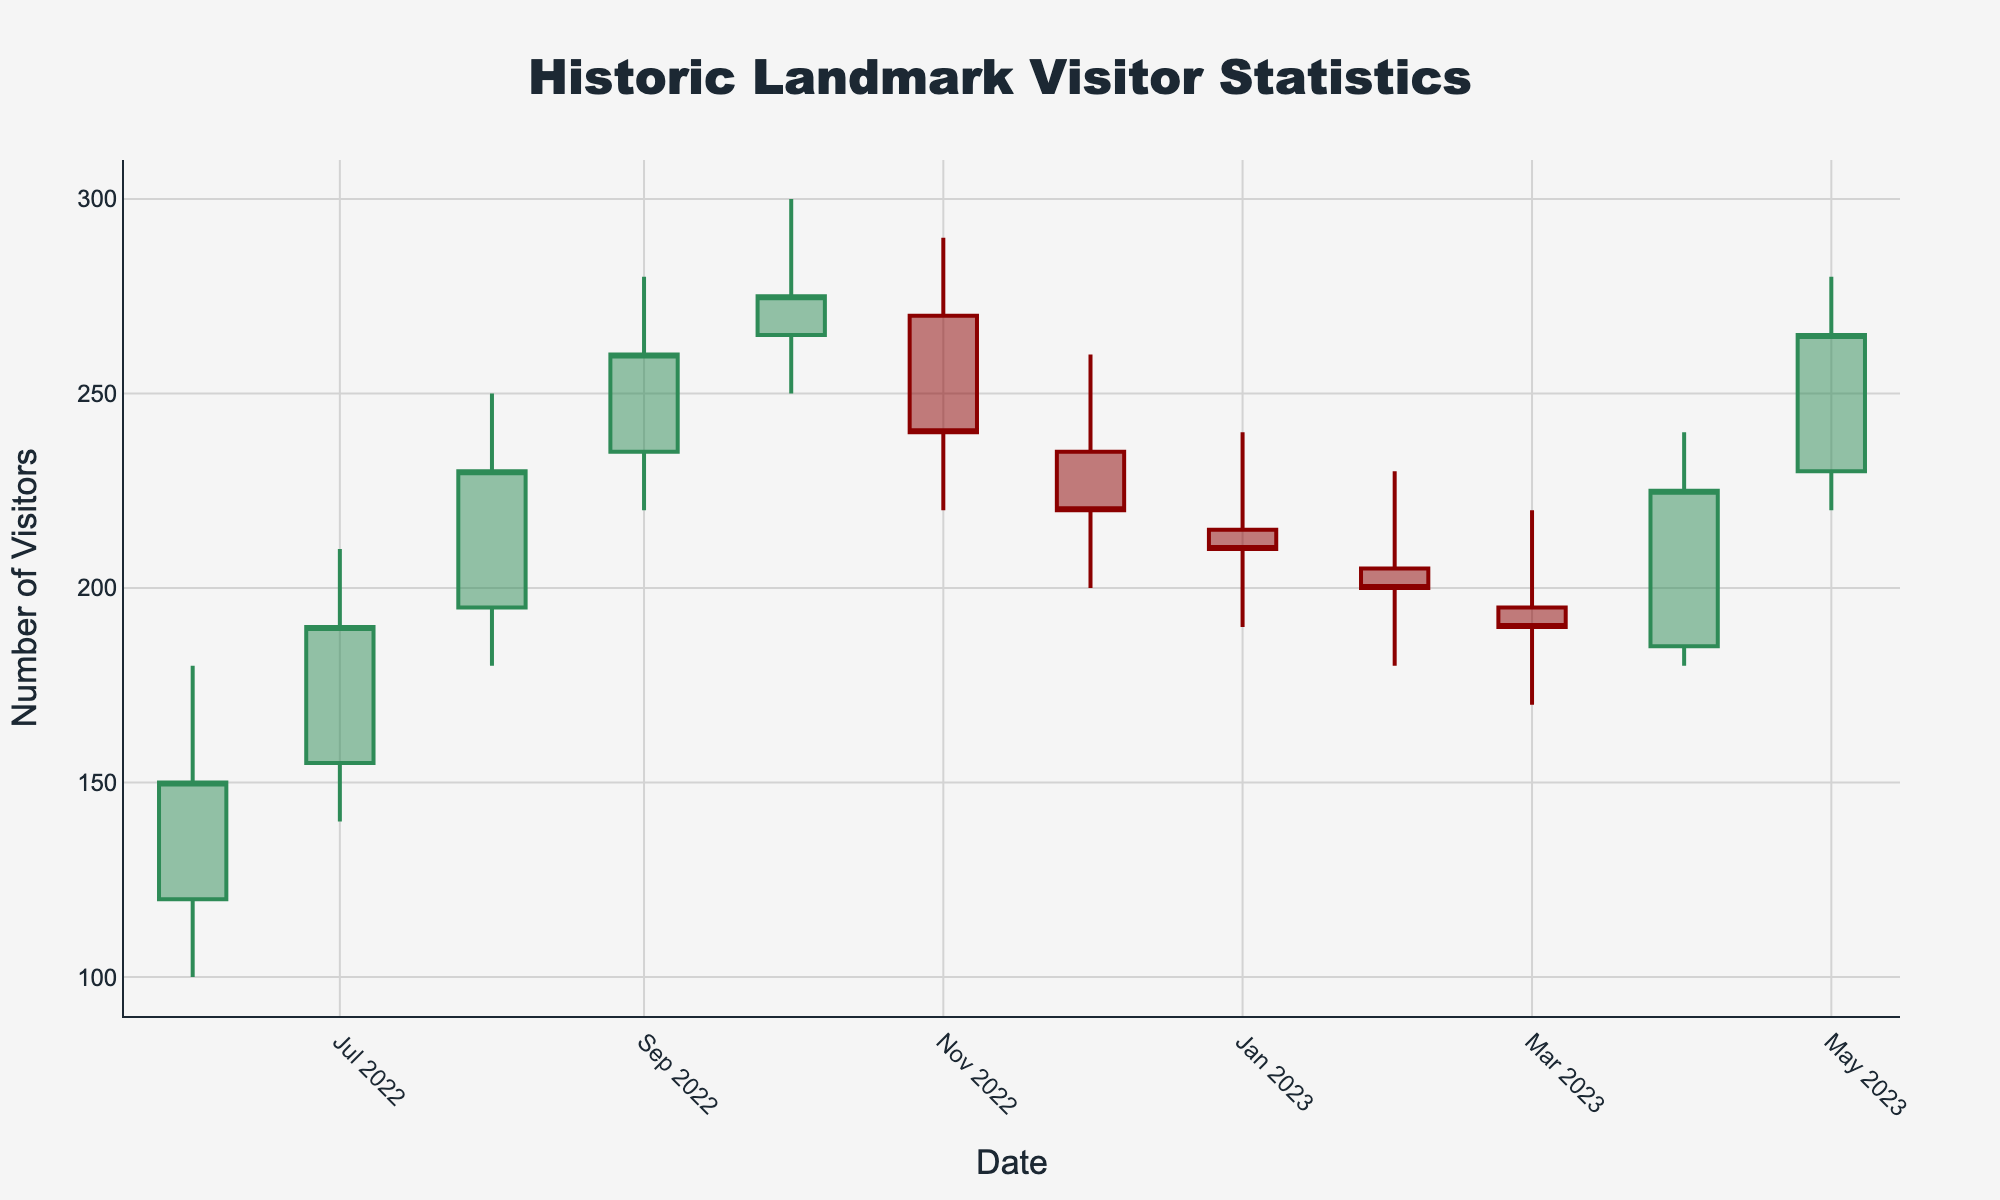What is the title of the chart? The title of the chart is displayed at the top center of the figure and reads "Historic Landmark Visitor Statistics".
Answer: Historic Landmark Visitor Statistics What information is provided on the x-axis of the chart? The x-axis of the chart provides the dates from June 2022 to May 2023.
Answer: Dates from June 2022 to May 2023 When did the highest number of visitors occur, and how many were there? The highest number of visitors occurred in October 2022, with the high point reaching 300 visitors.
Answer: October 2022, 300 visitors Which month had the largest fluctuation in visitor numbers, and what is the difference between the high and low values for that month? The largest fluctuation in visitor numbers occurred in August 2022, with a high of 250 visitors and a low of 180 visitors. The difference is 250 - 180 = 70.
Answer: August 2022, 70 visitors What is the trend in visitor numbers from December 2022 to February 2023? From December 2022 to February 2023, the visitor numbers generally declined. In December the closing value was 220, in January it was 210, and in February it was 200.
Answer: Declining Which month had the lowest closing visitor number, and what was that number? The month with the lowest closing visitor number was February 2023, with a close of 200 visitors.
Answer: February 2023, 200 visitors How do visitor numbers in May 2023 compare to those in June 2022? In May 2023, the closing visitor number was 265, while in June 2022 it was 150. To compare, we calculate 265 - 150 = 115, showing an increase.
Answer: May 2023 is higher by 115 visitors Calculate the average high visitor number for the period. To find the average high, sum all the high values (180 + 210 + 250 + 280 + 300 + 290 + 260 + 240 + 230 + 220 + 240 + 280) = 2980, and then divide by the number of months, which is 12. So, 2980 / 12 ≈ 248.33.
Answer: 248.33 During which season did the landmark witness the highest peak in visitors, and what was the numerical peak? The highest peak was in the fall (October 2022) with a high of 300 visitors.
Answer: Fall, 300 visitors What general pattern can be observed from the data in terms of visitor fluctuations over the year? The general pattern observed shows an increase in visitors during the summer months, peaking in fall, followed by a decline through the winter and a rise again in spring.
Answer: Increase in summer, peak in fall, decline in winter, rise in spring 